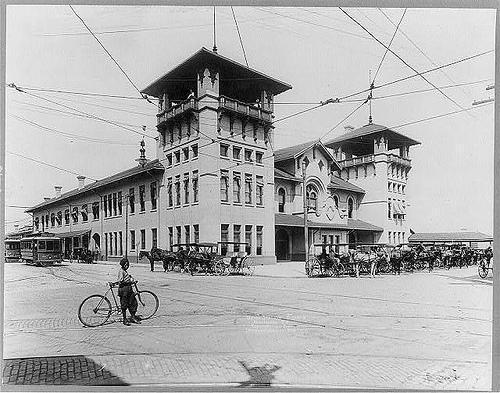How many bicycles?
Give a very brief answer. 1. 